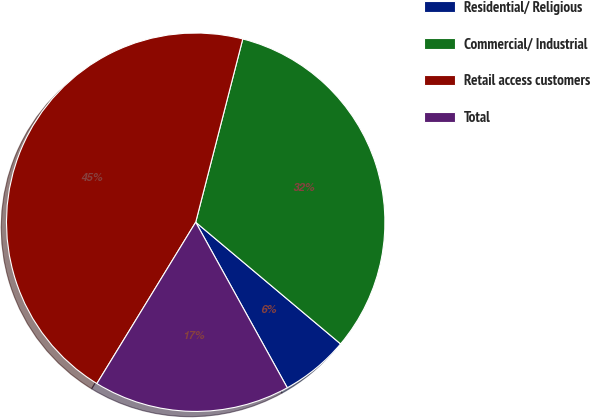Convert chart. <chart><loc_0><loc_0><loc_500><loc_500><pie_chart><fcel>Residential/ Religious<fcel>Commercial/ Industrial<fcel>Retail access customers<fcel>Total<nl><fcel>5.84%<fcel>32.12%<fcel>45.26%<fcel>16.79%<nl></chart> 